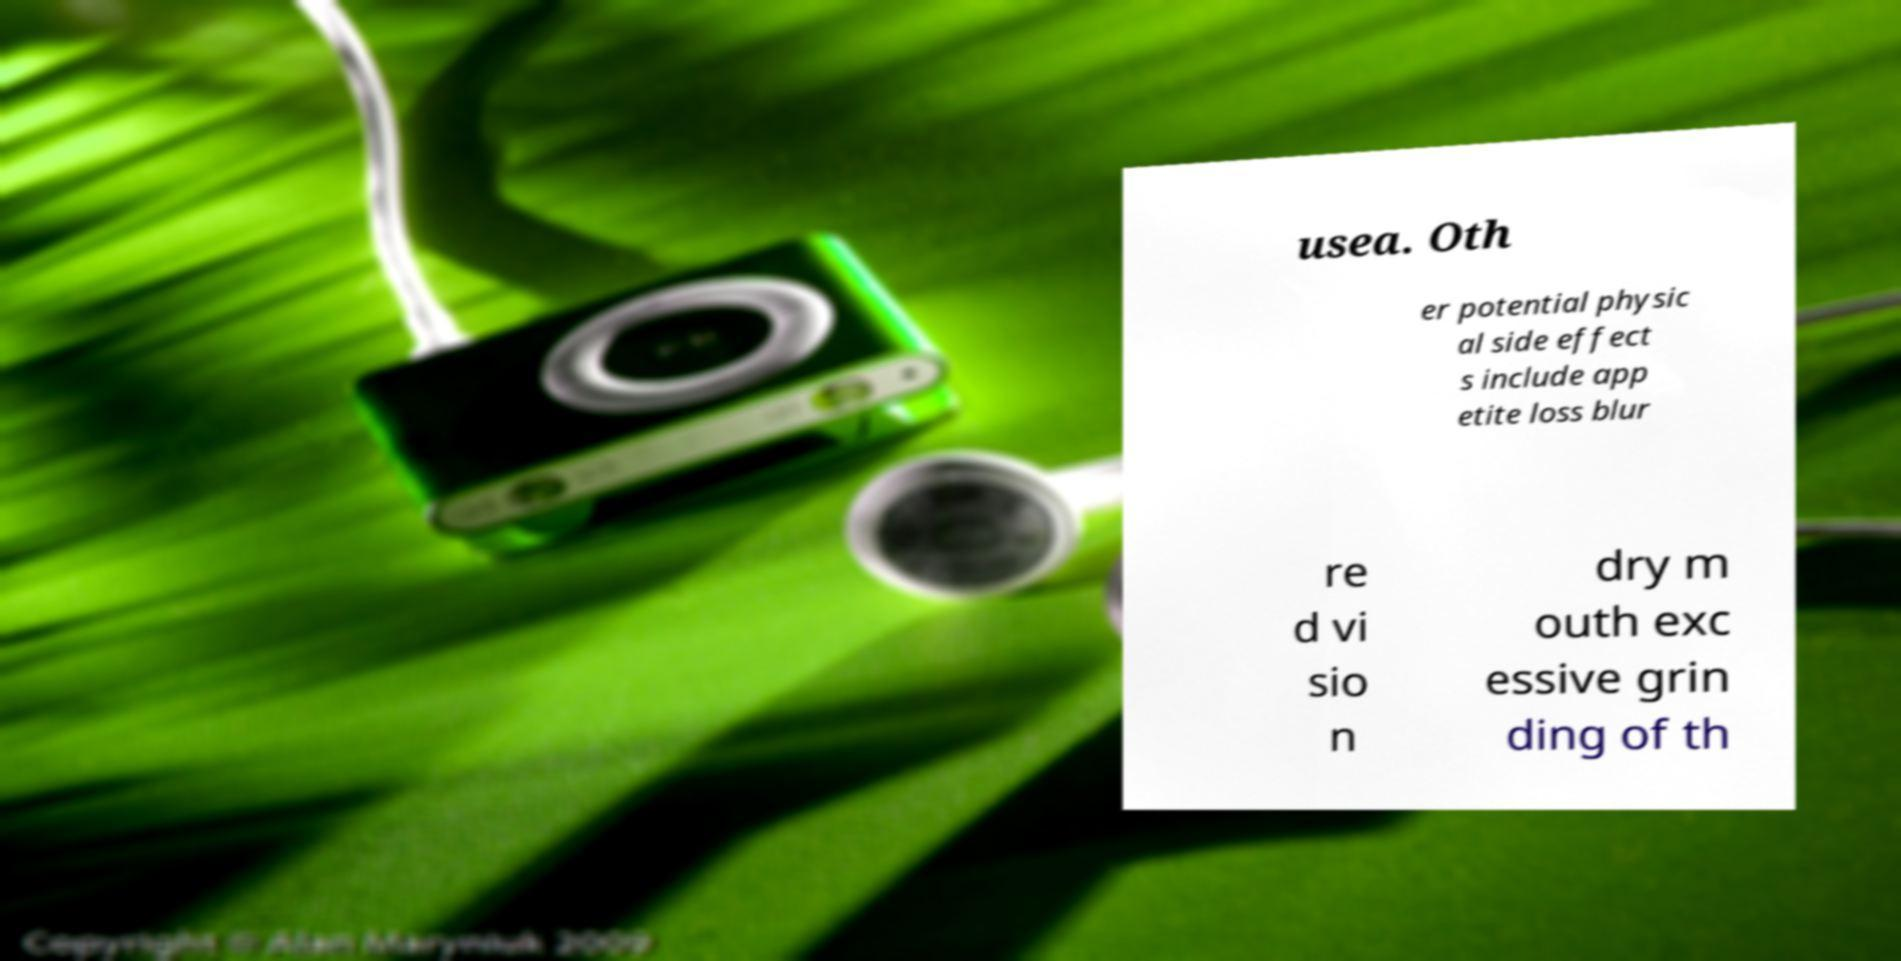Can you read and provide the text displayed in the image?This photo seems to have some interesting text. Can you extract and type it out for me? usea. Oth er potential physic al side effect s include app etite loss blur re d vi sio n dry m outh exc essive grin ding of th 